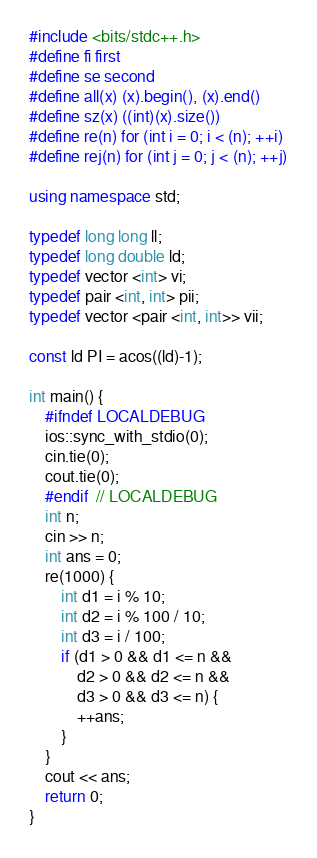<code> <loc_0><loc_0><loc_500><loc_500><_C++_>#include <bits/stdc++.h>
#define fi first
#define se second
#define all(x) (x).begin(), (x).end()
#define sz(x) ((int)(x).size())
#define re(n) for (int i = 0; i < (n); ++i)
#define rej(n) for (int j = 0; j < (n); ++j)

using namespace std;

typedef long long ll;
typedef long double ld;
typedef vector <int> vi;
typedef pair <int, int> pii;
typedef vector <pair <int, int>> vii;

const ld PI = acos((ld)-1);

int main() {
    #ifndef LOCALDEBUG
    ios::sync_with_stdio(0);
    cin.tie(0);
    cout.tie(0);
    #endif  // LOCALDEBUG
    int n;
    cin >> n;
    int ans = 0;
    re(1000) {
        int d1 = i % 10;
        int d2 = i % 100 / 10;
        int d3 = i / 100;
        if (d1 > 0 && d1 <= n &&
            d2 > 0 && d2 <= n &&
            d3 > 0 && d3 <= n) {
            ++ans;
        }
    }
    cout << ans;
    return 0;
}
</code> 